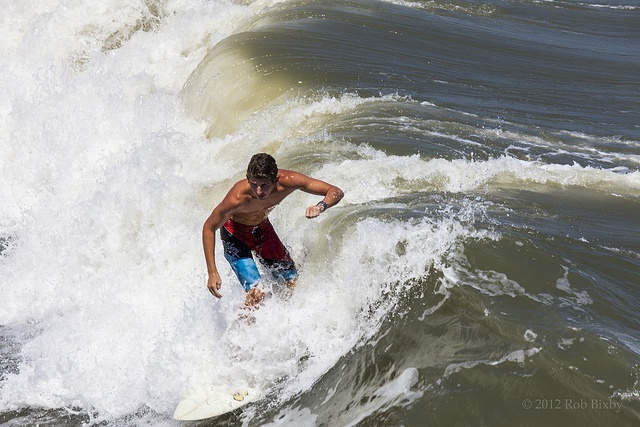Describe the objects in this image and their specific colors. I can see people in lightgray, black, maroon, and brown tones and surfboard in lightgray, darkgray, beige, and gray tones in this image. 